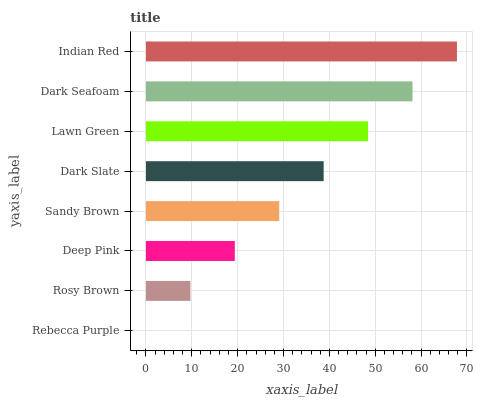Is Rebecca Purple the minimum?
Answer yes or no. Yes. Is Indian Red the maximum?
Answer yes or no. Yes. Is Rosy Brown the minimum?
Answer yes or no. No. Is Rosy Brown the maximum?
Answer yes or no. No. Is Rosy Brown greater than Rebecca Purple?
Answer yes or no. Yes. Is Rebecca Purple less than Rosy Brown?
Answer yes or no. Yes. Is Rebecca Purple greater than Rosy Brown?
Answer yes or no. No. Is Rosy Brown less than Rebecca Purple?
Answer yes or no. No. Is Dark Slate the high median?
Answer yes or no. Yes. Is Sandy Brown the low median?
Answer yes or no. Yes. Is Dark Seafoam the high median?
Answer yes or no. No. Is Dark Seafoam the low median?
Answer yes or no. No. 